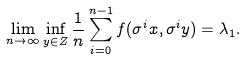<formula> <loc_0><loc_0><loc_500><loc_500>\lim _ { n \to \infty } \inf _ { y \in Z } \frac { 1 } { n } \sum _ { i = 0 } ^ { n - 1 } f ( \sigma ^ { i } x , \sigma ^ { i } y ) = \lambda _ { 1 } .</formula> 